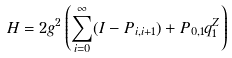<formula> <loc_0><loc_0><loc_500><loc_500>H = 2 g ^ { 2 } \left ( \sum _ { i = 0 } ^ { \infty } ( I - P _ { i , i + 1 } ) + P _ { 0 , 1 } q ^ { Z } _ { 1 } \right )</formula> 